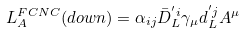Convert formula to latex. <formula><loc_0><loc_0><loc_500><loc_500>L _ { A } ^ { F C N C } ( d o w n ) = \alpha _ { i j } \bar { D } _ { L } ^ { ^ { \prime } i } \gamma _ { \mu } d _ { L } ^ { ^ { \prime } j } A ^ { \mu }</formula> 